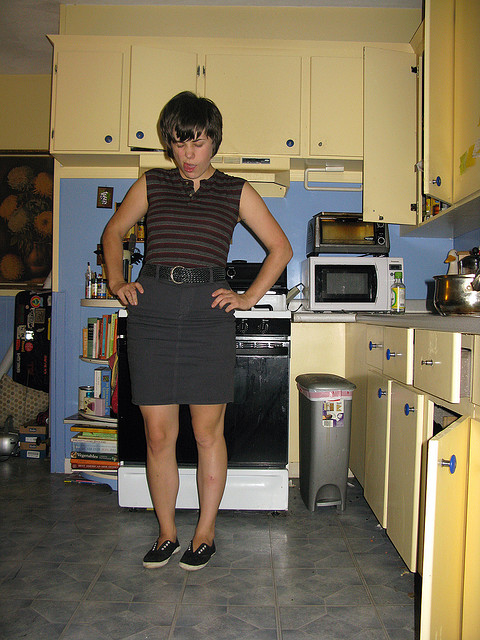Can you tell what items are on top of the fridge? On top of the fridge, there appears to be a decorative item or a small artwork alongside what might be a kitchen storage box or bin. Is there anything interesting about the decorations in this kitchen? Yes, the kitchen's use of color, notably the bright yellow cabinets, paired with complementing shades of blue and cream in the utensils and fixtures, creates a cheerful, inviting space. This color scheme, along with the sunflower artwork, adds a warm, personalized touch, alluding to a sunny, farmhouse-inspired vibe. 